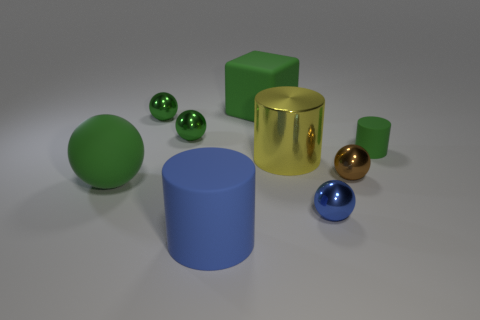Subtract all large balls. How many balls are left? 4 Subtract all gray cylinders. How many green balls are left? 3 Subtract all brown spheres. How many spheres are left? 4 Subtract 2 balls. How many balls are left? 3 Subtract all balls. How many objects are left? 4 Subtract 0 gray cylinders. How many objects are left? 9 Subtract all purple spheres. Subtract all red cylinders. How many spheres are left? 5 Subtract all small purple metal balls. Subtract all large matte spheres. How many objects are left? 8 Add 6 tiny rubber cylinders. How many tiny rubber cylinders are left? 7 Add 5 big red metallic cylinders. How many big red metallic cylinders exist? 5 